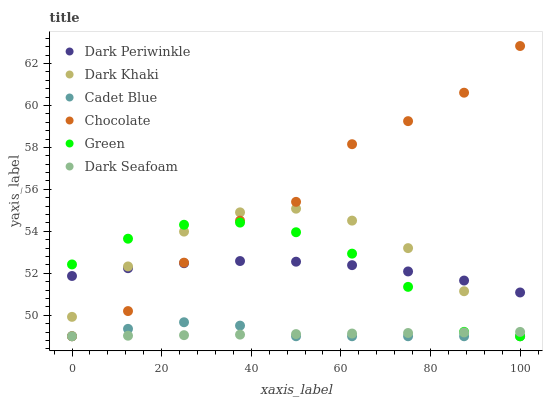Does Dark Seafoam have the minimum area under the curve?
Answer yes or no. Yes. Does Chocolate have the maximum area under the curve?
Answer yes or no. Yes. Does Dark Khaki have the minimum area under the curve?
Answer yes or no. No. Does Dark Khaki have the maximum area under the curve?
Answer yes or no. No. Is Dark Seafoam the smoothest?
Answer yes or no. Yes. Is Chocolate the roughest?
Answer yes or no. Yes. Is Dark Khaki the smoothest?
Answer yes or no. No. Is Dark Khaki the roughest?
Answer yes or no. No. Does Cadet Blue have the lowest value?
Answer yes or no. Yes. Does Dark Periwinkle have the lowest value?
Answer yes or no. No. Does Chocolate have the highest value?
Answer yes or no. Yes. Does Dark Khaki have the highest value?
Answer yes or no. No. Is Cadet Blue less than Dark Periwinkle?
Answer yes or no. Yes. Is Dark Periwinkle greater than Dark Seafoam?
Answer yes or no. Yes. Does Cadet Blue intersect Dark Khaki?
Answer yes or no. Yes. Is Cadet Blue less than Dark Khaki?
Answer yes or no. No. Is Cadet Blue greater than Dark Khaki?
Answer yes or no. No. Does Cadet Blue intersect Dark Periwinkle?
Answer yes or no. No. 